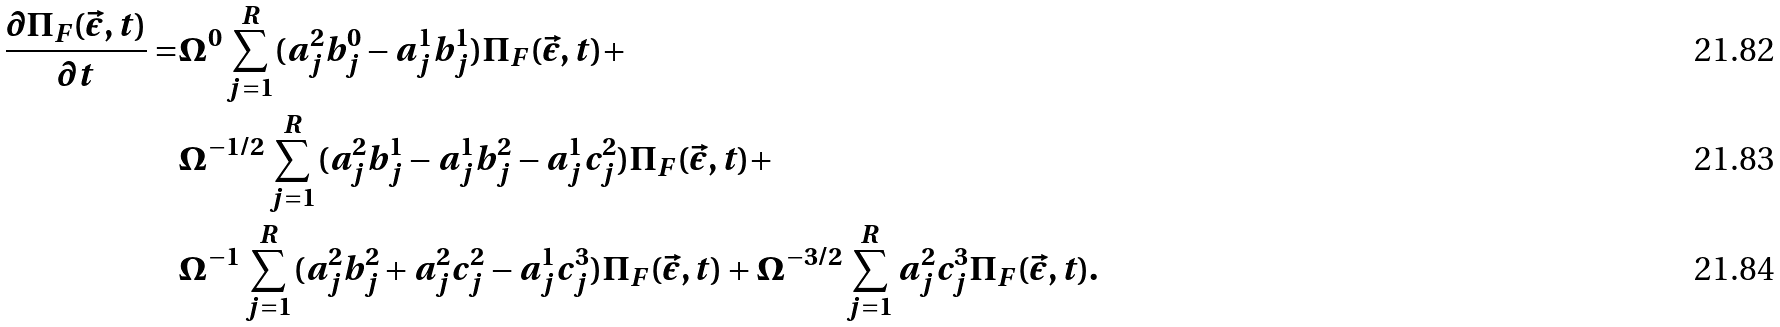<formula> <loc_0><loc_0><loc_500><loc_500>\frac { \partial \Pi _ { F } ( \vec { \epsilon } , t ) } { \partial t } = & \Omega ^ { 0 } \sum _ { j = 1 } ^ { R } ( a _ { j } ^ { 2 } b _ { j } ^ { 0 } - a _ { j } ^ { 1 } b _ { j } ^ { 1 } ) \Pi _ { F } ( \vec { \epsilon } , t ) + \\ & \Omega ^ { - 1 / 2 } \sum _ { j = 1 } ^ { R } ( a _ { j } ^ { 2 } b _ { j } ^ { 1 } - a _ { j } ^ { 1 } b _ { j } ^ { 2 } - a _ { j } ^ { 1 } c _ { j } ^ { 2 } ) \Pi _ { F } ( \vec { \epsilon } , t ) + \\ & \Omega ^ { - 1 } \sum _ { j = 1 } ^ { R } ( a _ { j } ^ { 2 } b _ { j } ^ { 2 } + a _ { j } ^ { 2 } c _ { j } ^ { 2 } - a _ { j } ^ { 1 } c _ { j } ^ { 3 } ) \Pi _ { F } ( \vec { \epsilon } , t ) + \Omega ^ { - 3 / 2 } \sum _ { j = 1 } ^ { R } a _ { j } ^ { 2 } c _ { j } ^ { 3 } \Pi _ { F } ( \vec { \epsilon } , t ) .</formula> 